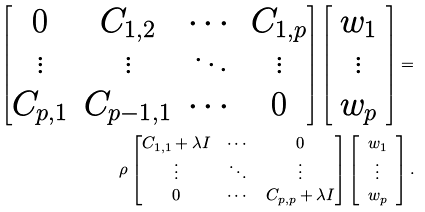Convert formula to latex. <formula><loc_0><loc_0><loc_500><loc_500>\begin{bmatrix} 0 & C _ { 1 , 2 } & \cdots & C _ { 1 , p } \\ \vdots & \vdots & \ddots & \vdots \\ C _ { p , 1 } & C _ { { p - 1 } , 1 } & \cdots & 0 \end{bmatrix} \left [ \begin{array} { c } w _ { 1 } \\ \vdots \\ w _ { p } \end{array} \right ] = & \\ \rho \begin{bmatrix} C _ { 1 , 1 } + \lambda I & \cdots & 0 \\ \vdots & \ddots & \vdots \\ 0 & \cdots & C _ { p , p } + \lambda I \end{bmatrix} \left [ \begin{array} { c } w _ { 1 } \\ \vdots \\ w _ { p } \end{array} \right ] .</formula> 